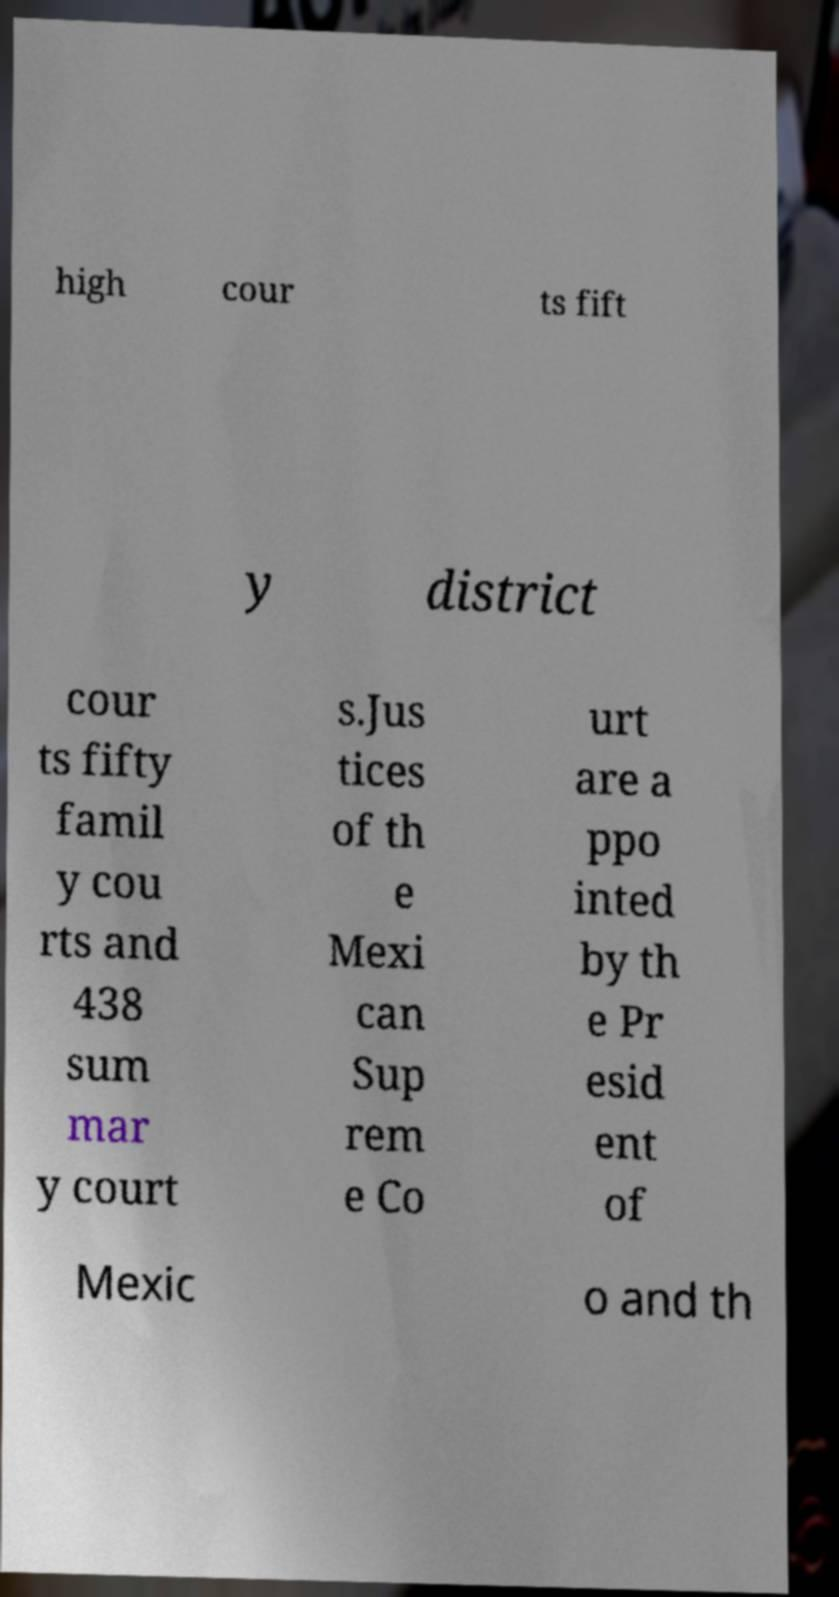What messages or text are displayed in this image? I need them in a readable, typed format. high cour ts fift y district cour ts fifty famil y cou rts and 438 sum mar y court s.Jus tices of th e Mexi can Sup rem e Co urt are a ppo inted by th e Pr esid ent of Mexic o and th 